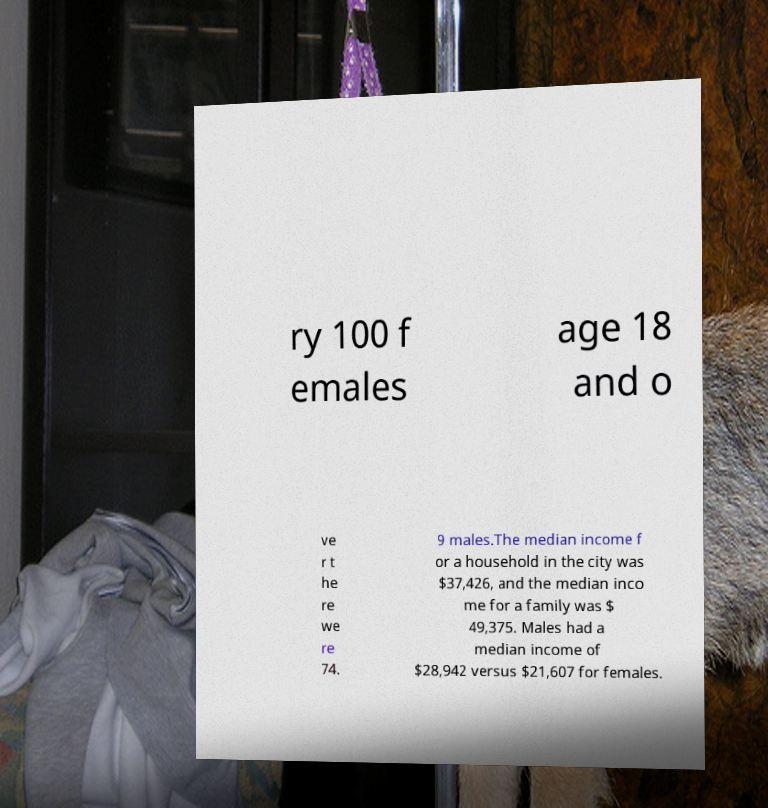Could you assist in decoding the text presented in this image and type it out clearly? ry 100 f emales age 18 and o ve r t he re we re 74. 9 males.The median income f or a household in the city was $37,426, and the median inco me for a family was $ 49,375. Males had a median income of $28,942 versus $21,607 for females. 